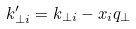<formula> <loc_0><loc_0><loc_500><loc_500>k ^ { \prime } _ { \perp i } = k _ { \perp i } - x _ { i } q _ { \perp }</formula> 